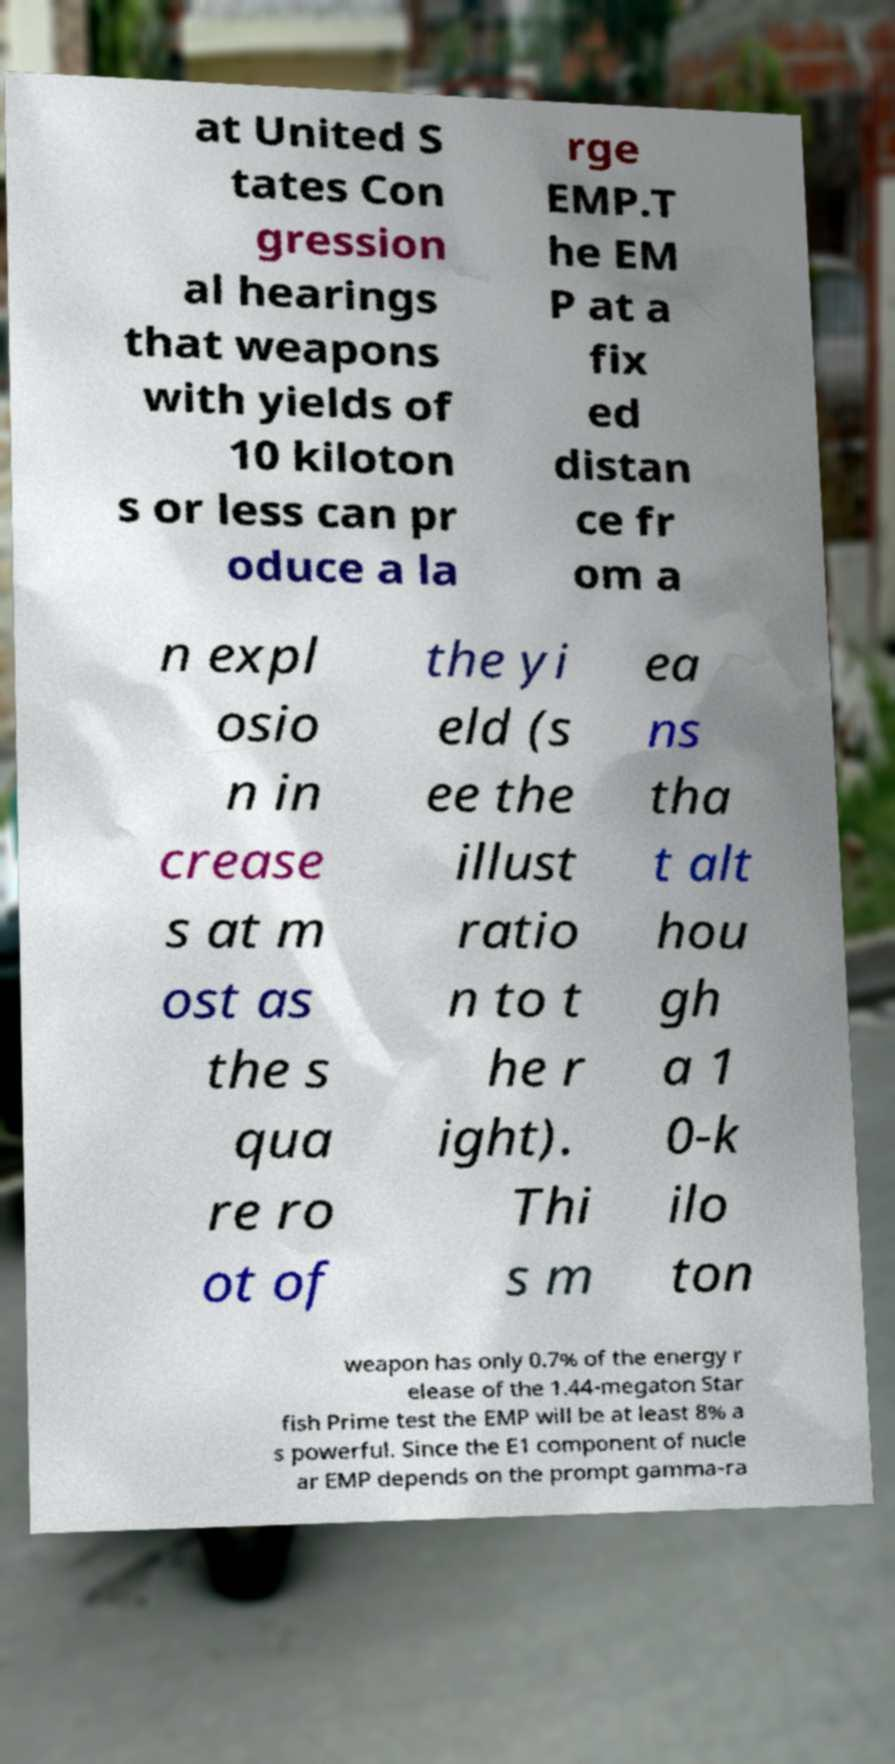Could you extract and type out the text from this image? at United S tates Con gression al hearings that weapons with yields of 10 kiloton s or less can pr oduce a la rge EMP.T he EM P at a fix ed distan ce fr om a n expl osio n in crease s at m ost as the s qua re ro ot of the yi eld (s ee the illust ratio n to t he r ight). Thi s m ea ns tha t alt hou gh a 1 0-k ilo ton weapon has only 0.7% of the energy r elease of the 1.44-megaton Star fish Prime test the EMP will be at least 8% a s powerful. Since the E1 component of nucle ar EMP depends on the prompt gamma-ra 